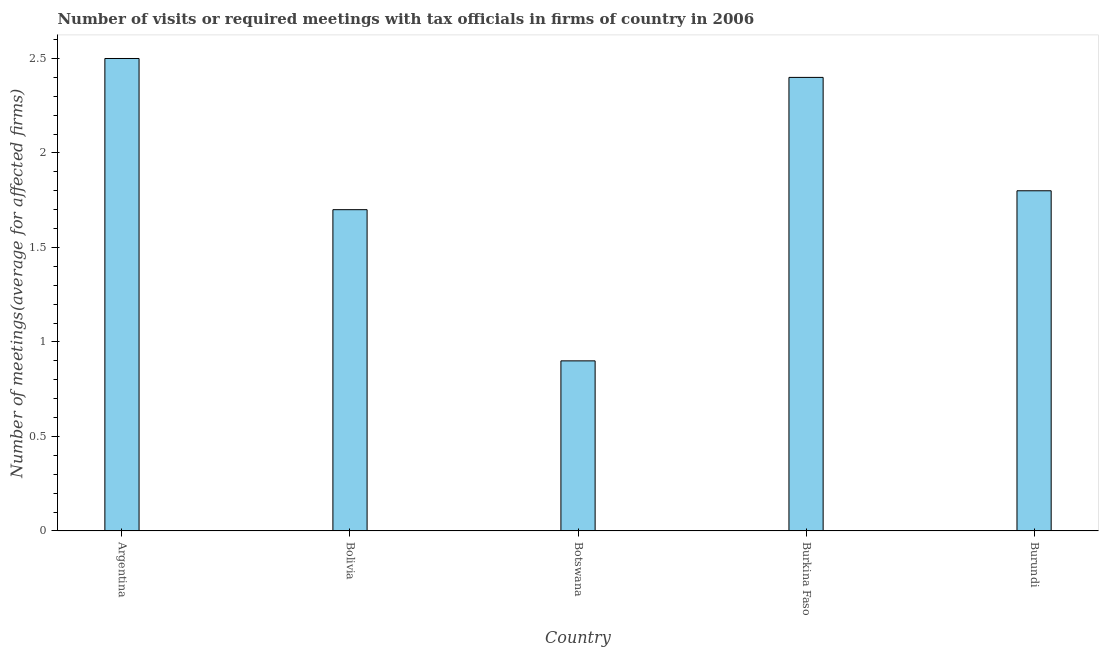What is the title of the graph?
Your answer should be compact. Number of visits or required meetings with tax officials in firms of country in 2006. What is the label or title of the X-axis?
Provide a short and direct response. Country. What is the label or title of the Y-axis?
Offer a very short reply. Number of meetings(average for affected firms). What is the number of required meetings with tax officials in Burundi?
Offer a very short reply. 1.8. Across all countries, what is the maximum number of required meetings with tax officials?
Offer a terse response. 2.5. Across all countries, what is the minimum number of required meetings with tax officials?
Keep it short and to the point. 0.9. In which country was the number of required meetings with tax officials maximum?
Give a very brief answer. Argentina. In which country was the number of required meetings with tax officials minimum?
Offer a very short reply. Botswana. What is the sum of the number of required meetings with tax officials?
Keep it short and to the point. 9.3. What is the difference between the number of required meetings with tax officials in Argentina and Burundi?
Give a very brief answer. 0.7. What is the average number of required meetings with tax officials per country?
Ensure brevity in your answer.  1.86. What is the median number of required meetings with tax officials?
Your answer should be very brief. 1.8. In how many countries, is the number of required meetings with tax officials greater than 0.5 ?
Your answer should be compact. 5. What is the ratio of the number of required meetings with tax officials in Bolivia to that in Burkina Faso?
Offer a very short reply. 0.71. What is the difference between the highest and the second highest number of required meetings with tax officials?
Ensure brevity in your answer.  0.1. In how many countries, is the number of required meetings with tax officials greater than the average number of required meetings with tax officials taken over all countries?
Your response must be concise. 2. What is the difference between two consecutive major ticks on the Y-axis?
Provide a succinct answer. 0.5. What is the Number of meetings(average for affected firms) in Argentina?
Your response must be concise. 2.5. What is the Number of meetings(average for affected firms) of Bolivia?
Keep it short and to the point. 1.7. What is the Number of meetings(average for affected firms) in Burkina Faso?
Provide a short and direct response. 2.4. What is the difference between the Number of meetings(average for affected firms) in Argentina and Bolivia?
Your answer should be compact. 0.8. What is the difference between the Number of meetings(average for affected firms) in Bolivia and Botswana?
Make the answer very short. 0.8. What is the difference between the Number of meetings(average for affected firms) in Bolivia and Burundi?
Ensure brevity in your answer.  -0.1. What is the ratio of the Number of meetings(average for affected firms) in Argentina to that in Bolivia?
Ensure brevity in your answer.  1.47. What is the ratio of the Number of meetings(average for affected firms) in Argentina to that in Botswana?
Offer a terse response. 2.78. What is the ratio of the Number of meetings(average for affected firms) in Argentina to that in Burkina Faso?
Provide a short and direct response. 1.04. What is the ratio of the Number of meetings(average for affected firms) in Argentina to that in Burundi?
Your response must be concise. 1.39. What is the ratio of the Number of meetings(average for affected firms) in Bolivia to that in Botswana?
Keep it short and to the point. 1.89. What is the ratio of the Number of meetings(average for affected firms) in Bolivia to that in Burkina Faso?
Give a very brief answer. 0.71. What is the ratio of the Number of meetings(average for affected firms) in Bolivia to that in Burundi?
Your answer should be compact. 0.94. What is the ratio of the Number of meetings(average for affected firms) in Burkina Faso to that in Burundi?
Provide a short and direct response. 1.33. 